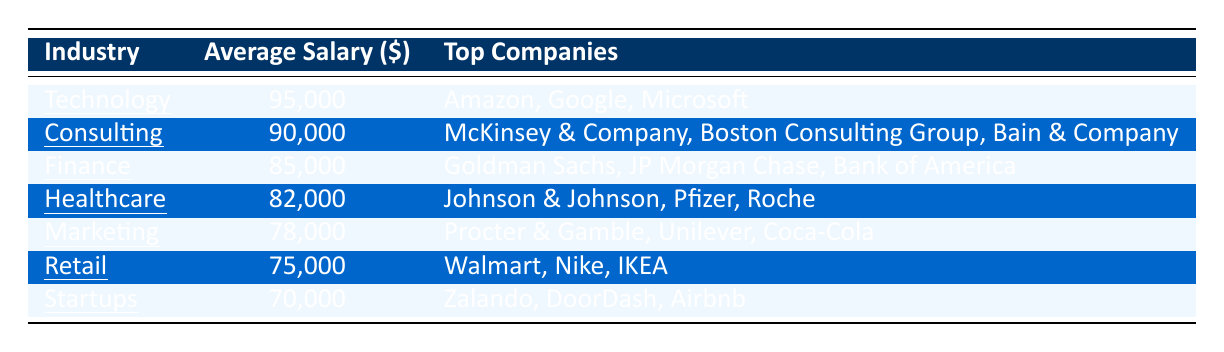What is the average salary for graduates in the Technology industry? The average salary for the Technology industry is directly listed in the table under the average salary column. It shows 95,000.
Answer: 95,000 Which industry has the highest average salary? By comparing the average salary figures in the table, Technology has the highest average salary at 95,000.
Answer: Technology What are the top companies in the Consulting industry? The table provides a specific list of companies under the top companies column for the Consulting industry, which includes McKinsey & Company, Boston Consulting Group, and Bain & Company.
Answer: McKinsey & Company, Boston Consulting Group, Bain & Company What is the difference in average salary between the Finance and Marketing industries? The average salary for Finance is 85,000, and for Marketing, it is 78,000. The difference can be calculated as 85,000 - 78,000 = 7,000.
Answer: 7,000 Is the average salary for graduates in the Retail industry higher than that of the Startups industry? The average salary for Retail is 75,000 and for Startups is 70,000. Since 75,000 is greater than 70,000, the statement is true.
Answer: Yes What is the average salary of the Healthcare and Retail industries combined? From the table, the average salary for Healthcare is 82,000 and for Retail is 75,000. Adding them gives 82,000 + 75,000 = 157,000. To find the average: 157,000 / 2 = 78,500.
Answer: 78,500 Which industry has an average salary above 80,000? Referring to the average salaries in the table, Consulting (90,000), Finance (85,000), Technology (95,000), and Healthcare (82,000) all have salaries above 80,000.
Answer: Consulting, Finance, Technology, Healthcare If I want to work at a top company in the Startups industry, which companies can I consider? The table lists Zalando, DoorDash, and Airbnb as the top companies in the Startups industry.
Answer: Zalando, DoorDash, Airbnb How many industries listed have an average salary of less than 80,000? From the table, only the Startups industry (70,000) and Marketing industry (78,000) have average salaries below 80,000. Thus, there are two such industries.
Answer: 2 What is the average salary for all industries combined? Summing up all the average salaries: 90,000 + 85,000 + 95,000 + 78,000 + 82,000 + 70,000 + 75,000 = 675,000. There are 7 industries, so the average salary is calculated as 675,000 / 7 = 96,428.57 (rounding to 96,429 for simplicity).
Answer: 96,429 